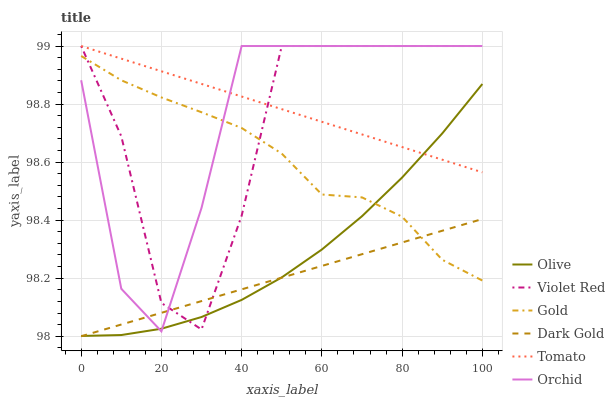Does Dark Gold have the minimum area under the curve?
Answer yes or no. Yes. Does Tomato have the maximum area under the curve?
Answer yes or no. Yes. Does Violet Red have the minimum area under the curve?
Answer yes or no. No. Does Violet Red have the maximum area under the curve?
Answer yes or no. No. Is Tomato the smoothest?
Answer yes or no. Yes. Is Violet Red the roughest?
Answer yes or no. Yes. Is Gold the smoothest?
Answer yes or no. No. Is Gold the roughest?
Answer yes or no. No. Does Dark Gold have the lowest value?
Answer yes or no. Yes. Does Violet Red have the lowest value?
Answer yes or no. No. Does Orchid have the highest value?
Answer yes or no. Yes. Does Gold have the highest value?
Answer yes or no. No. Is Dark Gold less than Tomato?
Answer yes or no. Yes. Is Tomato greater than Dark Gold?
Answer yes or no. Yes. Does Violet Red intersect Tomato?
Answer yes or no. Yes. Is Violet Red less than Tomato?
Answer yes or no. No. Is Violet Red greater than Tomato?
Answer yes or no. No. Does Dark Gold intersect Tomato?
Answer yes or no. No. 